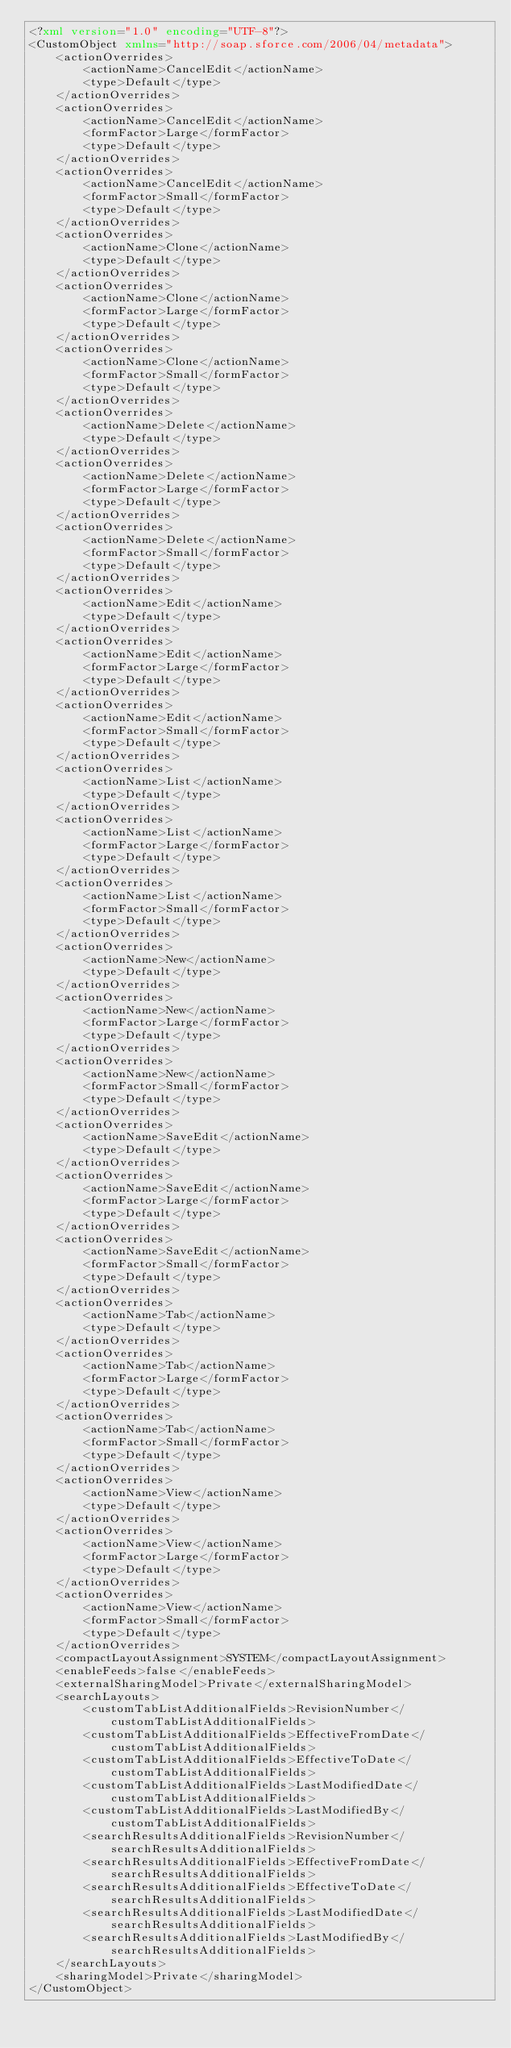<code> <loc_0><loc_0><loc_500><loc_500><_XML_><?xml version="1.0" encoding="UTF-8"?>
<CustomObject xmlns="http://soap.sforce.com/2006/04/metadata">
    <actionOverrides>
        <actionName>CancelEdit</actionName>
        <type>Default</type>
    </actionOverrides>
    <actionOverrides>
        <actionName>CancelEdit</actionName>
        <formFactor>Large</formFactor>
        <type>Default</type>
    </actionOverrides>
    <actionOverrides>
        <actionName>CancelEdit</actionName>
        <formFactor>Small</formFactor>
        <type>Default</type>
    </actionOverrides>
    <actionOverrides>
        <actionName>Clone</actionName>
        <type>Default</type>
    </actionOverrides>
    <actionOverrides>
        <actionName>Clone</actionName>
        <formFactor>Large</formFactor>
        <type>Default</type>
    </actionOverrides>
    <actionOverrides>
        <actionName>Clone</actionName>
        <formFactor>Small</formFactor>
        <type>Default</type>
    </actionOverrides>
    <actionOverrides>
        <actionName>Delete</actionName>
        <type>Default</type>
    </actionOverrides>
    <actionOverrides>
        <actionName>Delete</actionName>
        <formFactor>Large</formFactor>
        <type>Default</type>
    </actionOverrides>
    <actionOverrides>
        <actionName>Delete</actionName>
        <formFactor>Small</formFactor>
        <type>Default</type>
    </actionOverrides>
    <actionOverrides>
        <actionName>Edit</actionName>
        <type>Default</type>
    </actionOverrides>
    <actionOverrides>
        <actionName>Edit</actionName>
        <formFactor>Large</formFactor>
        <type>Default</type>
    </actionOverrides>
    <actionOverrides>
        <actionName>Edit</actionName>
        <formFactor>Small</formFactor>
        <type>Default</type>
    </actionOverrides>
    <actionOverrides>
        <actionName>List</actionName>
        <type>Default</type>
    </actionOverrides>
    <actionOverrides>
        <actionName>List</actionName>
        <formFactor>Large</formFactor>
        <type>Default</type>
    </actionOverrides>
    <actionOverrides>
        <actionName>List</actionName>
        <formFactor>Small</formFactor>
        <type>Default</type>
    </actionOverrides>
    <actionOverrides>
        <actionName>New</actionName>
        <type>Default</type>
    </actionOverrides>
    <actionOverrides>
        <actionName>New</actionName>
        <formFactor>Large</formFactor>
        <type>Default</type>
    </actionOverrides>
    <actionOverrides>
        <actionName>New</actionName>
        <formFactor>Small</formFactor>
        <type>Default</type>
    </actionOverrides>
    <actionOverrides>
        <actionName>SaveEdit</actionName>
        <type>Default</type>
    </actionOverrides>
    <actionOverrides>
        <actionName>SaveEdit</actionName>
        <formFactor>Large</formFactor>
        <type>Default</type>
    </actionOverrides>
    <actionOverrides>
        <actionName>SaveEdit</actionName>
        <formFactor>Small</formFactor>
        <type>Default</type>
    </actionOverrides>
    <actionOverrides>
        <actionName>Tab</actionName>
        <type>Default</type>
    </actionOverrides>
    <actionOverrides>
        <actionName>Tab</actionName>
        <formFactor>Large</formFactor>
        <type>Default</type>
    </actionOverrides>
    <actionOverrides>
        <actionName>Tab</actionName>
        <formFactor>Small</formFactor>
        <type>Default</type>
    </actionOverrides>
    <actionOverrides>
        <actionName>View</actionName>
        <type>Default</type>
    </actionOverrides>
    <actionOverrides>
        <actionName>View</actionName>
        <formFactor>Large</formFactor>
        <type>Default</type>
    </actionOverrides>
    <actionOverrides>
        <actionName>View</actionName>
        <formFactor>Small</formFactor>
        <type>Default</type>
    </actionOverrides>
    <compactLayoutAssignment>SYSTEM</compactLayoutAssignment>
    <enableFeeds>false</enableFeeds>
    <externalSharingModel>Private</externalSharingModel>
    <searchLayouts>
        <customTabListAdditionalFields>RevisionNumber</customTabListAdditionalFields>
        <customTabListAdditionalFields>EffectiveFromDate</customTabListAdditionalFields>
        <customTabListAdditionalFields>EffectiveToDate</customTabListAdditionalFields>
        <customTabListAdditionalFields>LastModifiedDate</customTabListAdditionalFields>
        <customTabListAdditionalFields>LastModifiedBy</customTabListAdditionalFields>
        <searchResultsAdditionalFields>RevisionNumber</searchResultsAdditionalFields>
        <searchResultsAdditionalFields>EffectiveFromDate</searchResultsAdditionalFields>
        <searchResultsAdditionalFields>EffectiveToDate</searchResultsAdditionalFields>
        <searchResultsAdditionalFields>LastModifiedDate</searchResultsAdditionalFields>
        <searchResultsAdditionalFields>LastModifiedBy</searchResultsAdditionalFields>
    </searchLayouts>
    <sharingModel>Private</sharingModel>
</CustomObject>
</code> 